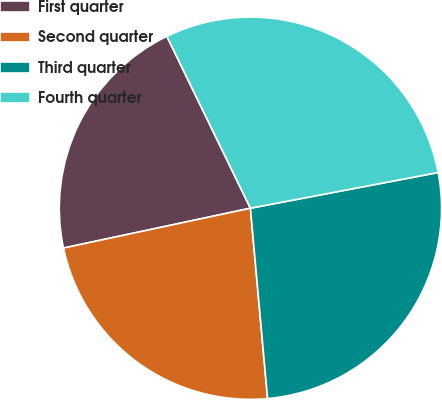<chart> <loc_0><loc_0><loc_500><loc_500><pie_chart><fcel>First quarter<fcel>Second quarter<fcel>Third quarter<fcel>Fourth quarter<nl><fcel>21.14%<fcel>23.09%<fcel>26.56%<fcel>29.21%<nl></chart> 